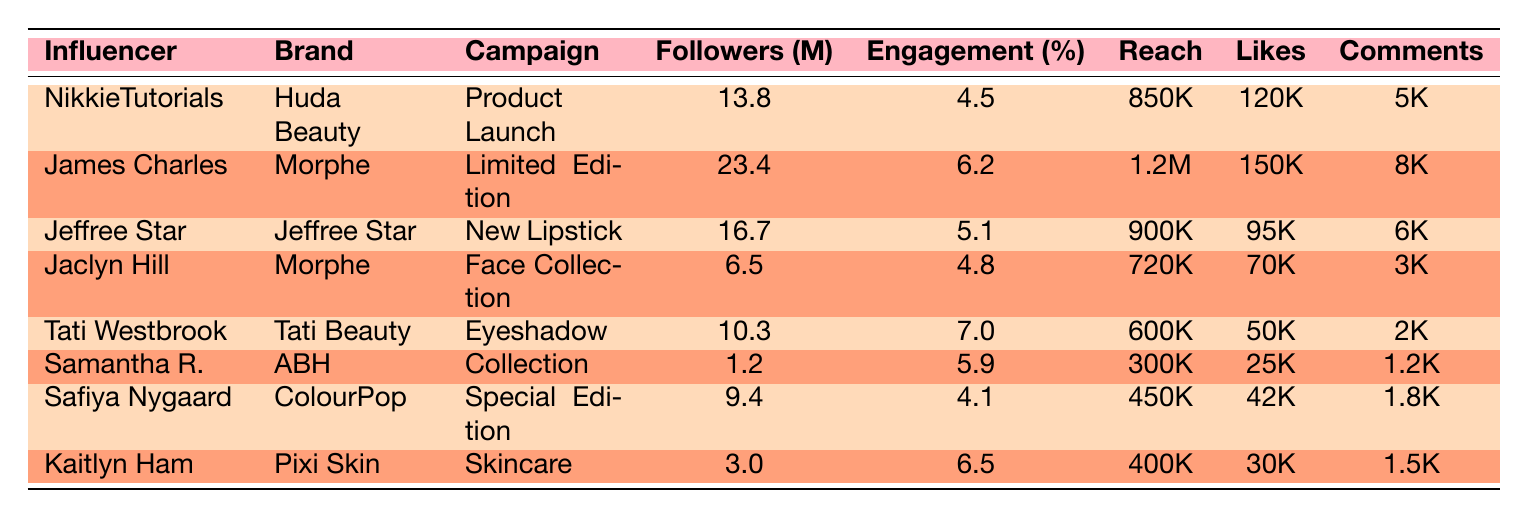What is the engagement rate of NikkieTutorials? The engagement rate for NikkieTutorials is listed in the table under the engagement rate column, which shows 4.5% for this influencer.
Answer: 4.5% Which influencer has the highest number of followers? By comparing the followers' column, James Charles has the highest followers at 23.4 million.
Answer: James Charles What is the average engagement rate of all the influencers in the table? To find the average, first, we sum the engagement rates: 4.5 + 6.2 + 5.1 + 4.8 + 7.0 + 5.9 + 4.1 + 6.5 = 43.1. There are 8 influencers, so the average is 43.1 / 8 = 5.3875, rounded to 5.39%.
Answer: 5.39% Did Jaclyn Hill's campaign reach more than 700,000 people? The reach for Jaclyn Hill is listed as 720,000, which exceeds 700,000, making the statement true.
Answer: Yes Which brand had the collaboration that resulted in the highest likes? By examining the likes column, the collaboration with James Charles for Morphe received 150,000 likes, which is the highest number compared to others.
Answer: Morphe What is the difference in comments between the campaigns of Tati Westbrook and NikkieTutorials? Tati Westbrook received 2,000 comments, while NikkieTutorials received 5,000 comments. The difference is 5000 - 2000 = 3000.
Answer: 3000 Which influencer had the lowest engagement rate? By comparing the engagement rates, Safiya Nygaard has the lowest engagement rate at 4.1%.
Answer: Safiya Nygaard How many influencers had a campaign engagement rate above 6%? From the table, the influencers with above 6% engagement rates are James Charles (6.2%), Tati Westbrook (7.0%), and Kaitlyn Ham (6.5%). This totals to three influencers.
Answer: 3 